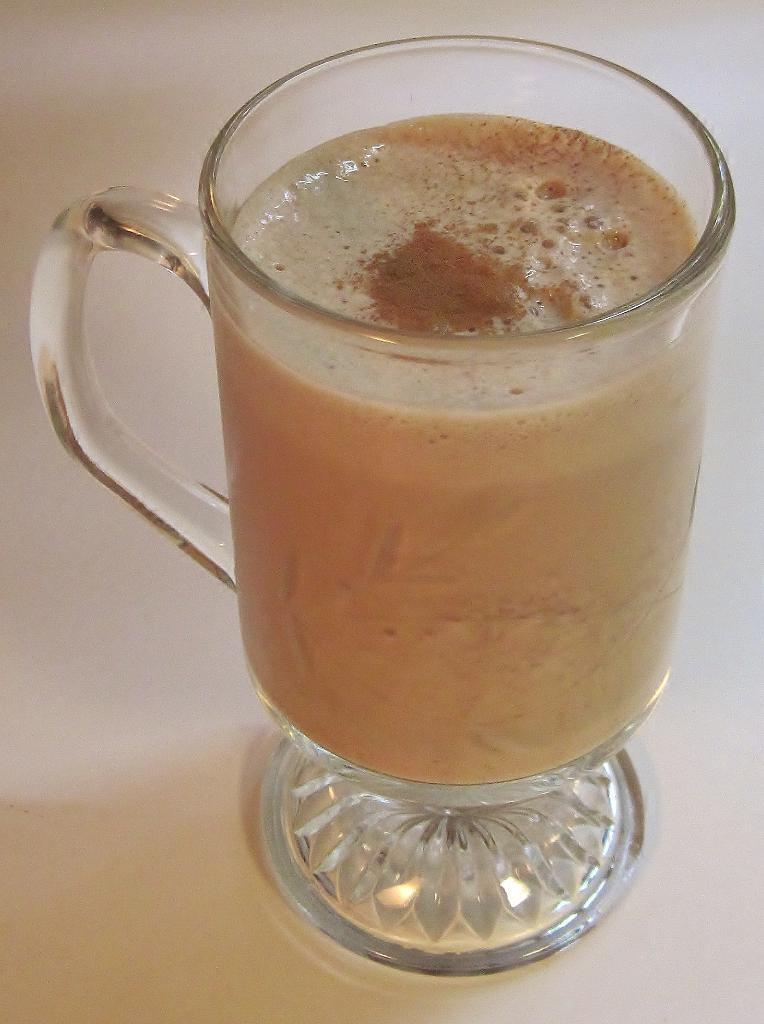What object is present in the image that can hold liquid? There is a mug in the image that can hold liquid. What is inside the mug? The mug contains liquid. Where is the mug placed in the image? The mug is on a platform. How many worms can be seen coiled around the mug in the image? There are no worms present in the image, and therefore no worms can be seen coiled around the mug. 